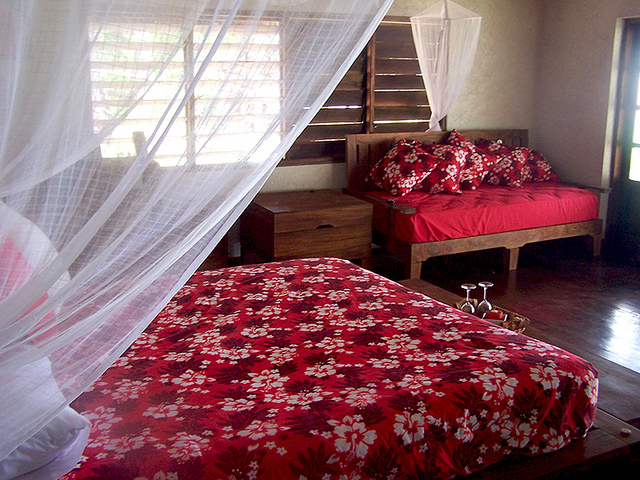What type of furniture piece is in the corner?
Answer the question using a single word or phrase. Couch 